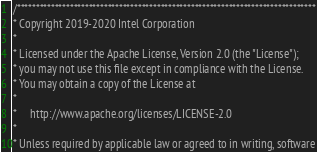<code> <loc_0><loc_0><loc_500><loc_500><_C++_>/*******************************************************************************
* Copyright 2019-2020 Intel Corporation
*
* Licensed under the Apache License, Version 2.0 (the "License");
* you may not use this file except in compliance with the License.
* You may obtain a copy of the License at
*
*     http://www.apache.org/licenses/LICENSE-2.0
*
* Unless required by applicable law or agreed to in writing, software</code> 